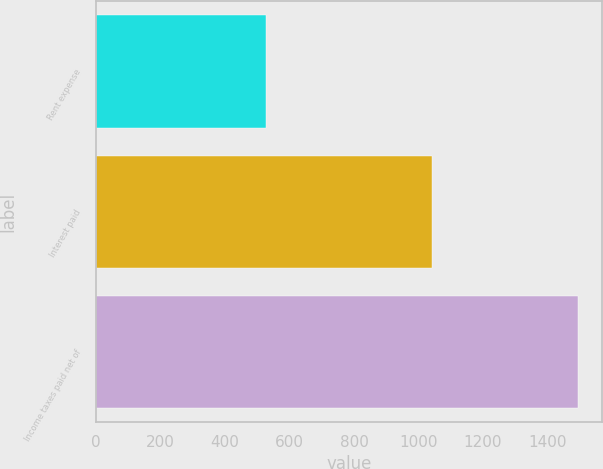Convert chart. <chart><loc_0><loc_0><loc_500><loc_500><bar_chart><fcel>Rent expense<fcel>Interest paid<fcel>Income taxes paid net of<nl><fcel>526<fcel>1043<fcel>1495<nl></chart> 